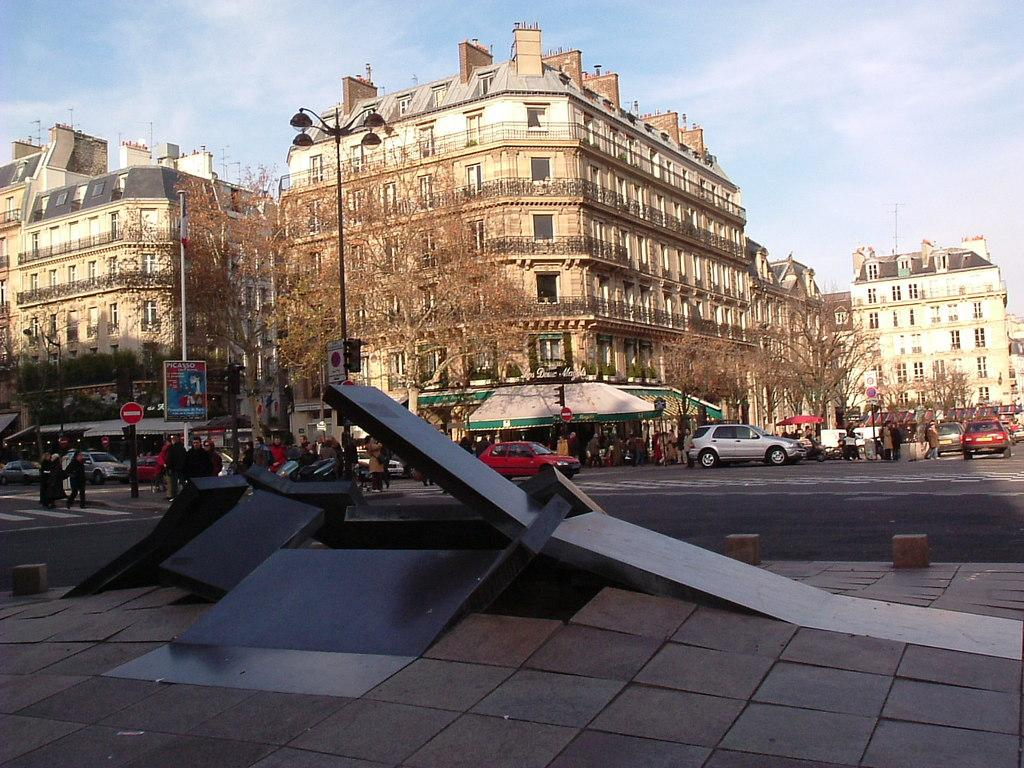What type of structures can be seen in the image? There are buildings in the image. What other natural elements are present in the image? There are trees in the image. What mode of transportation can be seen on the road in the image? Vehicles are present on the road in the image. Are there any people visible in the image? Yes, there are people visible in the image. What type of signage is present in the image? Boards are present in the image. What type of illumination is visible in the image? Lights are visible in the image. What type of storage or shelter structures are present in the image? There are sheds in the image. What type of material is present in the image for stacking or transporting goods? Pallets are present in the image. What type of natural material is visible in the image? Stones are visible in the image. What is visible at the top of the image? The sky is visible at the top of the image. What statement does the anger in the image make? There is no anger present in the image, so it cannot make any statements. What angle is the statement being made from in the image? There is no statement or angle present in the image. 